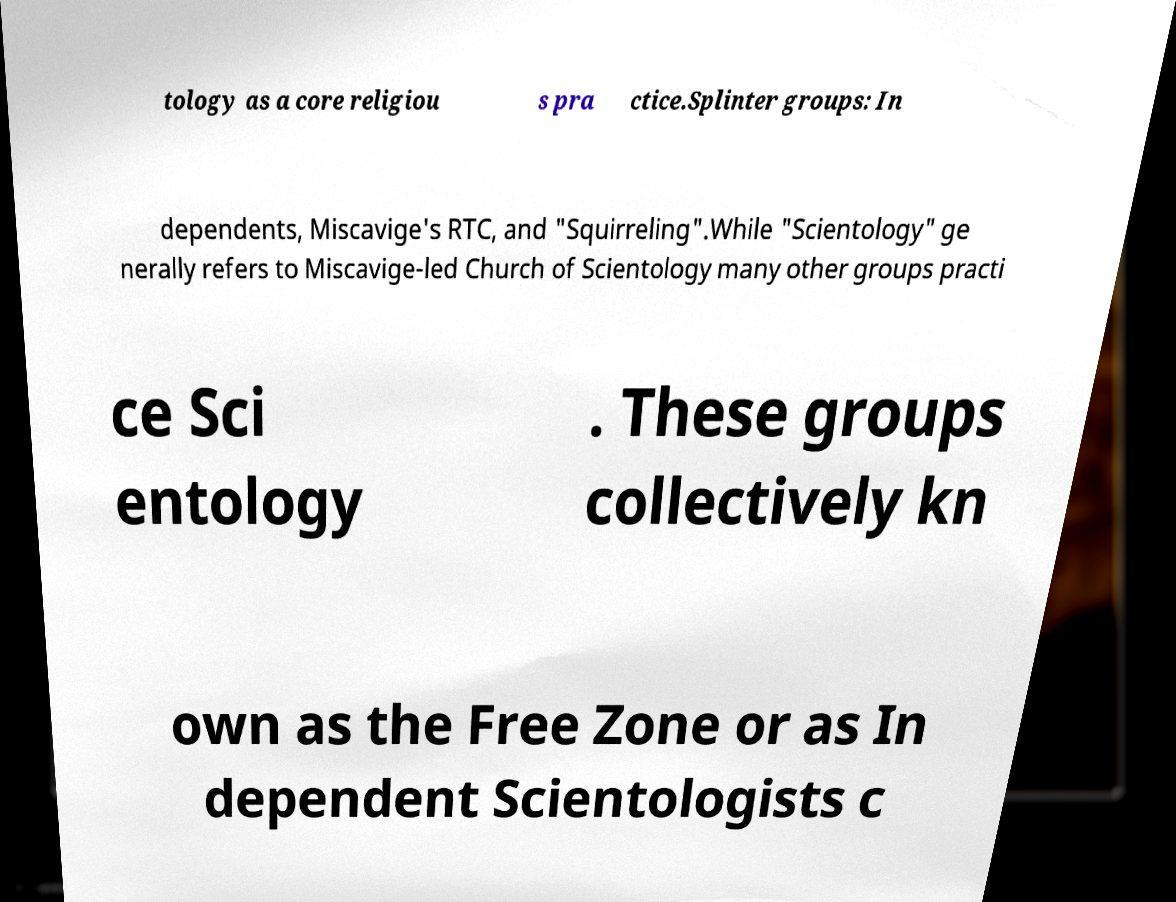Please read and relay the text visible in this image. What does it say? tology as a core religiou s pra ctice.Splinter groups: In dependents, Miscavige's RTC, and "Squirreling".While "Scientology" ge nerally refers to Miscavige-led Church of Scientology many other groups practi ce Sci entology . These groups collectively kn own as the Free Zone or as In dependent Scientologists c 